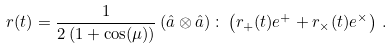Convert formula to latex. <formula><loc_0><loc_0><loc_500><loc_500>r ( t ) = \frac { 1 } { 2 \left ( 1 + \cos ( \mu ) \right ) } \left ( \hat { a } \otimes \hat { a } \right ) \colon \left ( r _ { + } ( t ) e ^ { + } + r _ { \times } ( t ) e ^ { \times } \right ) \, .</formula> 